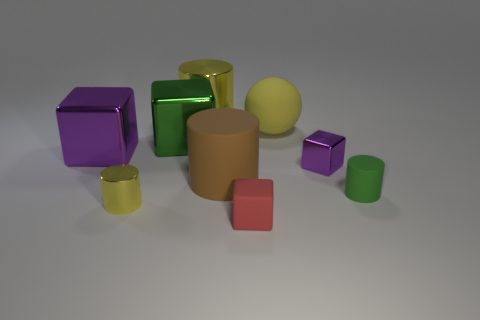Add 1 cyan rubber objects. How many objects exist? 10 Subtract all cylinders. How many objects are left? 5 Subtract all big green cubes. Subtract all big cylinders. How many objects are left? 6 Add 8 large green objects. How many large green objects are left? 9 Add 7 yellow cylinders. How many yellow cylinders exist? 9 Subtract 1 red blocks. How many objects are left? 8 